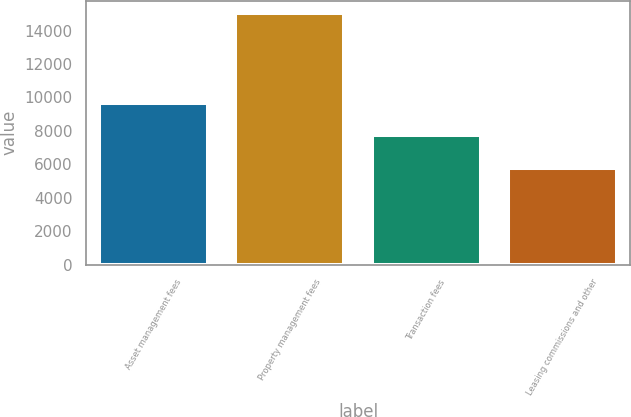Convert chart to OTSL. <chart><loc_0><loc_0><loc_500><loc_500><bar_chart><fcel>Asset management fees<fcel>Property management fees<fcel>Transaction fees<fcel>Leasing commissions and other<nl><fcel>9671<fcel>15031<fcel>7781<fcel>5806<nl></chart> 